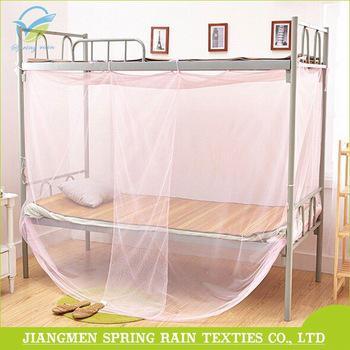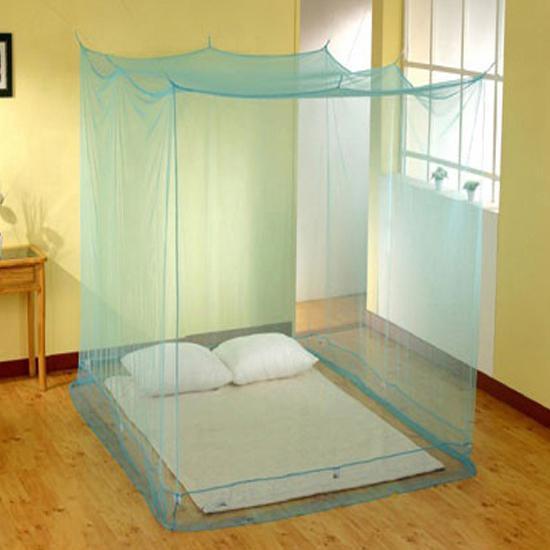The first image is the image on the left, the second image is the image on the right. Given the left and right images, does the statement "One of the beds is a bunk bed." hold true? Answer yes or no. Yes. The first image is the image on the left, the second image is the image on the right. Evaluate the accuracy of this statement regarding the images: "There are two canopies with at least one that is purple.". Is it true? Answer yes or no. No. 